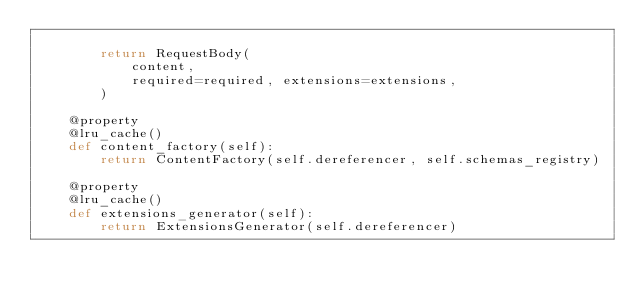<code> <loc_0><loc_0><loc_500><loc_500><_Python_>
        return RequestBody(
            content,
            required=required, extensions=extensions,
        )

    @property
    @lru_cache()
    def content_factory(self):
        return ContentFactory(self.dereferencer, self.schemas_registry)

    @property
    @lru_cache()
    def extensions_generator(self):
        return ExtensionsGenerator(self.dereferencer)
</code> 